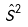<formula> <loc_0><loc_0><loc_500><loc_500>\hat { S } ^ { 2 }</formula> 